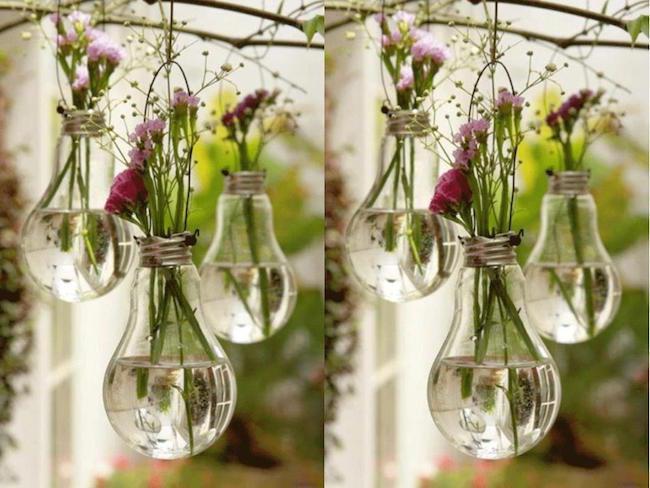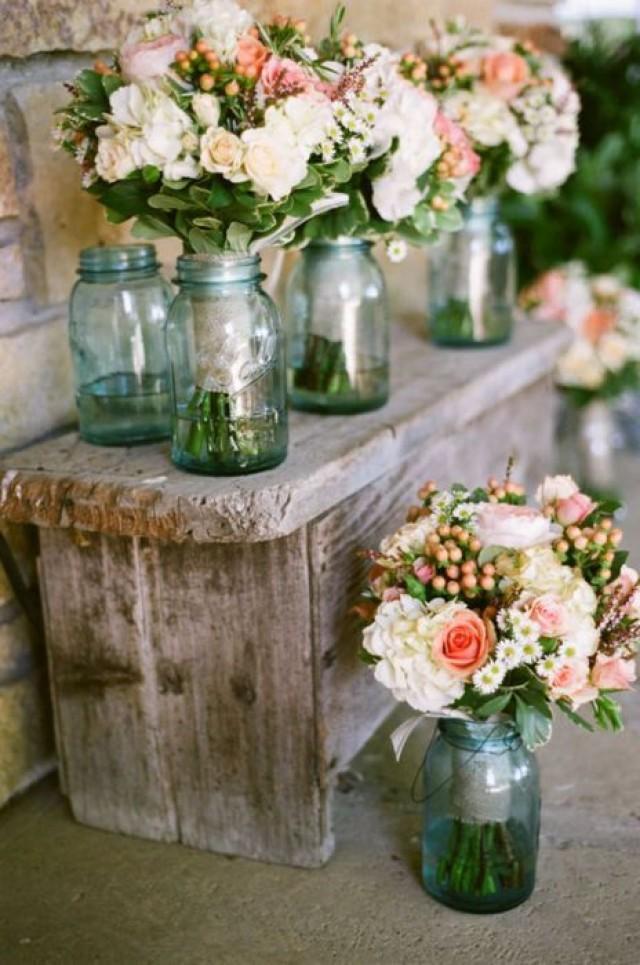The first image is the image on the left, the second image is the image on the right. For the images displayed, is the sentence "Every bottle/vase is on a table and contains at least one flower." factually correct? Answer yes or no. No. 